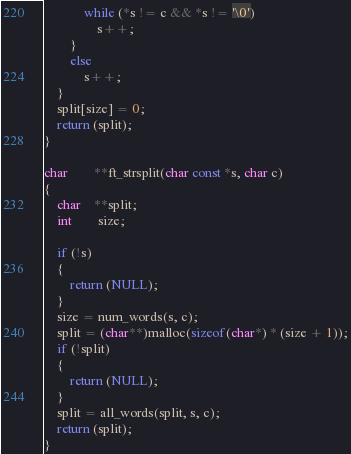Convert code to text. <code><loc_0><loc_0><loc_500><loc_500><_C_>			while (*s != c && *s != '\0')
				s++;
		}
		else
			s++;
	}
	split[size] = 0;
	return (split);
}

char		**ft_strsplit(char const *s, char c)
{
	char	**split;
	int		size;

	if (!s)
	{
		return (NULL);
	}
	size = num_words(s, c);
	split = (char**)malloc(sizeof(char*) * (size + 1));
	if (!split)
	{
		return (NULL);
	}
	split = all_words(split, s, c);
	return (split);
}
</code> 